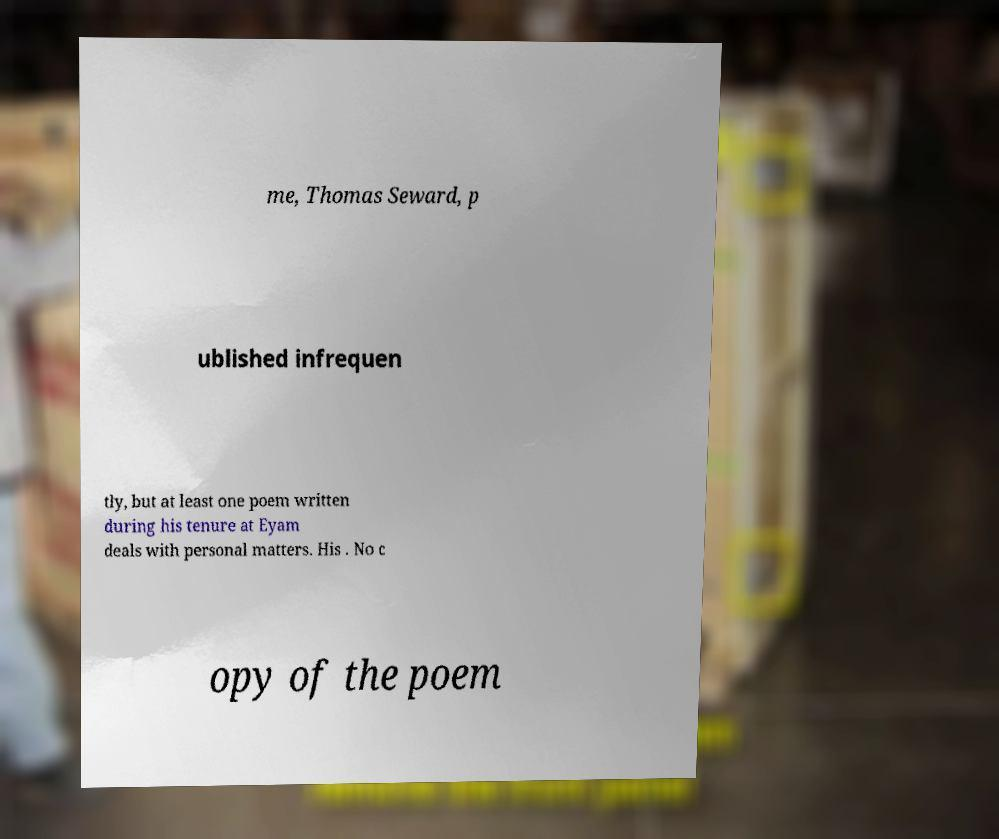Can you accurately transcribe the text from the provided image for me? me, Thomas Seward, p ublished infrequen tly, but at least one poem written during his tenure at Eyam deals with personal matters. His . No c opy of the poem 